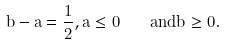Convert formula to latex. <formula><loc_0><loc_0><loc_500><loc_500>b - a = \frac { 1 } { 2 } , a \leq 0 \quad a n d b \geq 0 .</formula> 